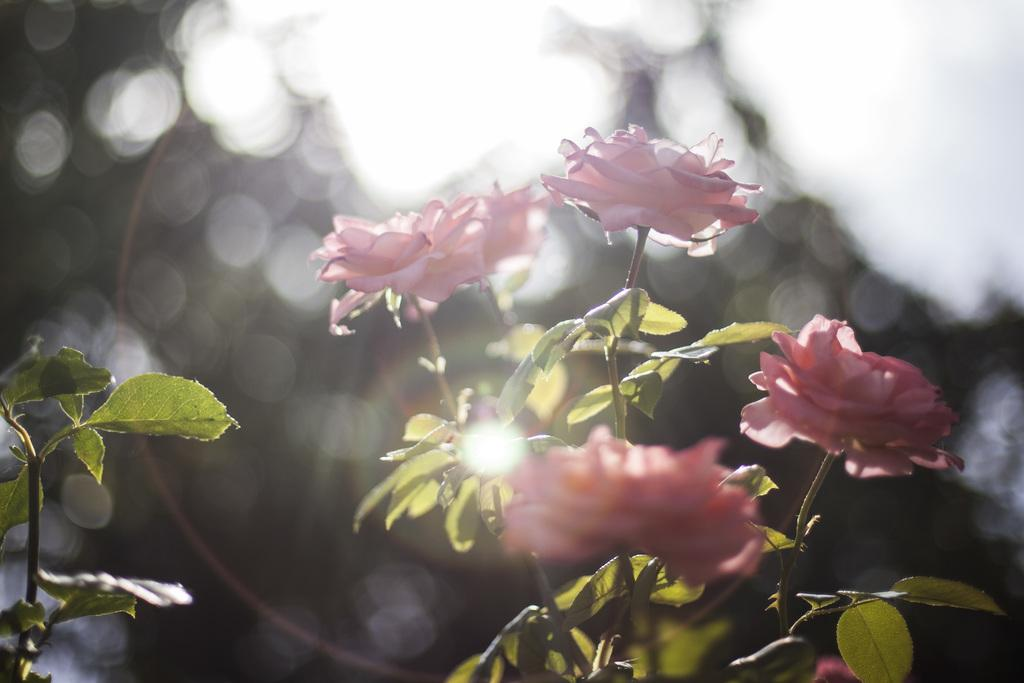What type of flora can be seen in the image? There are flowers and plants in the image. Can you describe the background of the image? The background of the image is blurry. Is there a goat driving a car in the image? No, there is no goat or car present in the image. 